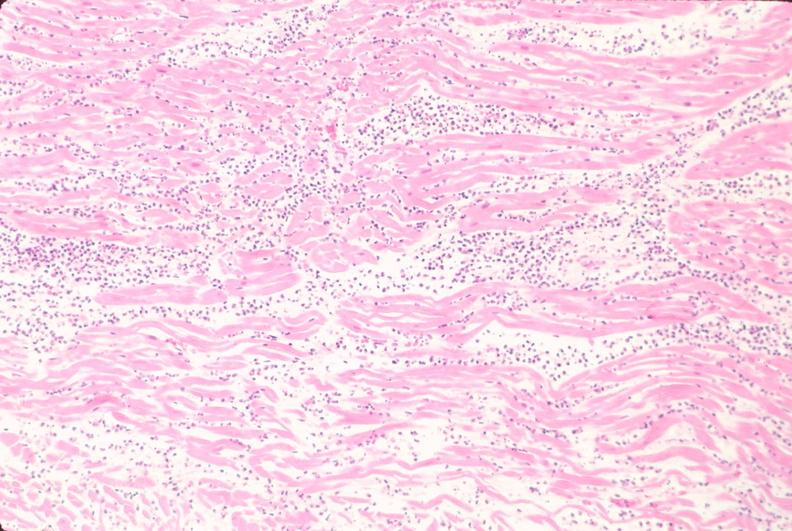what is present?
Answer the question using a single word or phrase. Cardiovascular 